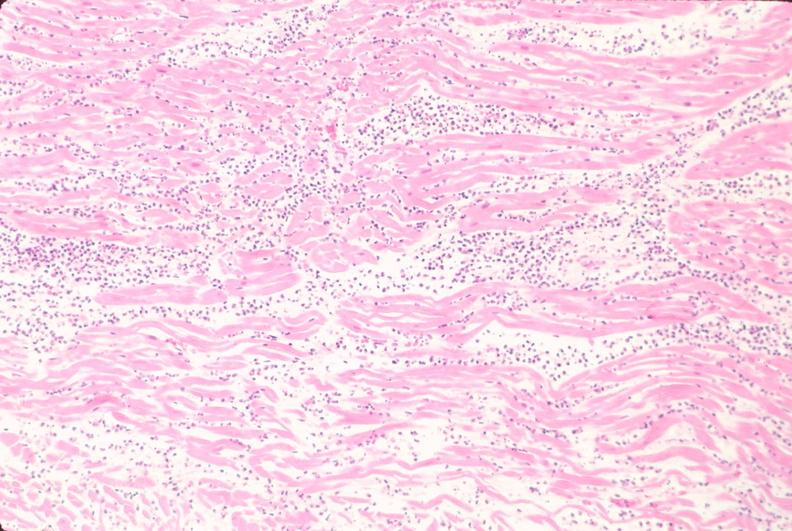what is present?
Answer the question using a single word or phrase. Cardiovascular 